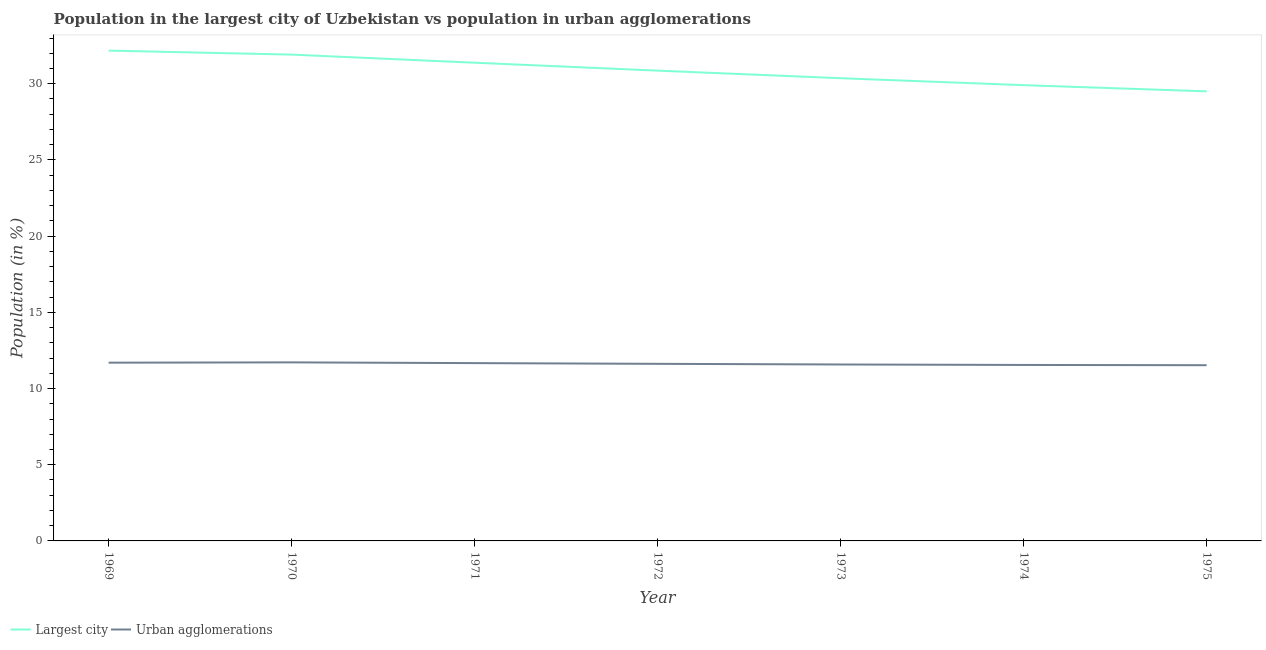Does the line corresponding to population in urban agglomerations intersect with the line corresponding to population in the largest city?
Make the answer very short. No. What is the population in urban agglomerations in 1973?
Offer a terse response. 11.58. Across all years, what is the maximum population in urban agglomerations?
Provide a succinct answer. 11.72. Across all years, what is the minimum population in the largest city?
Keep it short and to the point. 29.5. In which year was the population in the largest city maximum?
Provide a short and direct response. 1969. In which year was the population in urban agglomerations minimum?
Ensure brevity in your answer.  1975. What is the total population in the largest city in the graph?
Offer a very short reply. 216.09. What is the difference between the population in urban agglomerations in 1972 and that in 1975?
Provide a short and direct response. 0.09. What is the difference between the population in the largest city in 1972 and the population in urban agglomerations in 1975?
Your answer should be compact. 19.33. What is the average population in urban agglomerations per year?
Give a very brief answer. 11.62. In the year 1970, what is the difference between the population in the largest city and population in urban agglomerations?
Provide a succinct answer. 20.2. In how many years, is the population in urban agglomerations greater than 14 %?
Provide a succinct answer. 0. What is the ratio of the population in urban agglomerations in 1971 to that in 1974?
Your answer should be compact. 1.01. Is the difference between the population in urban agglomerations in 1970 and 1972 greater than the difference between the population in the largest city in 1970 and 1972?
Keep it short and to the point. No. What is the difference between the highest and the second highest population in urban agglomerations?
Offer a very short reply. 0.02. What is the difference between the highest and the lowest population in urban agglomerations?
Make the answer very short. 0.19. In how many years, is the population in urban agglomerations greater than the average population in urban agglomerations taken over all years?
Keep it short and to the point. 3. Is the population in the largest city strictly less than the population in urban agglomerations over the years?
Make the answer very short. No. What is the difference between two consecutive major ticks on the Y-axis?
Make the answer very short. 5. Does the graph contain any zero values?
Offer a terse response. No. Where does the legend appear in the graph?
Your response must be concise. Bottom left. What is the title of the graph?
Offer a very short reply. Population in the largest city of Uzbekistan vs population in urban agglomerations. What is the Population (in %) in Largest city in 1969?
Keep it short and to the point. 32.17. What is the Population (in %) of Urban agglomerations in 1969?
Provide a short and direct response. 11.7. What is the Population (in %) of Largest city in 1970?
Ensure brevity in your answer.  31.91. What is the Population (in %) in Urban agglomerations in 1970?
Your answer should be very brief. 11.72. What is the Population (in %) of Largest city in 1971?
Your response must be concise. 31.38. What is the Population (in %) of Urban agglomerations in 1971?
Ensure brevity in your answer.  11.67. What is the Population (in %) of Largest city in 1972?
Keep it short and to the point. 30.86. What is the Population (in %) of Urban agglomerations in 1972?
Provide a succinct answer. 11.62. What is the Population (in %) of Largest city in 1973?
Ensure brevity in your answer.  30.36. What is the Population (in %) of Urban agglomerations in 1973?
Offer a terse response. 11.58. What is the Population (in %) in Largest city in 1974?
Offer a terse response. 29.91. What is the Population (in %) of Urban agglomerations in 1974?
Your response must be concise. 11.55. What is the Population (in %) in Largest city in 1975?
Your answer should be compact. 29.5. What is the Population (in %) of Urban agglomerations in 1975?
Your answer should be very brief. 11.53. Across all years, what is the maximum Population (in %) of Largest city?
Provide a short and direct response. 32.17. Across all years, what is the maximum Population (in %) in Urban agglomerations?
Provide a succinct answer. 11.72. Across all years, what is the minimum Population (in %) in Largest city?
Offer a very short reply. 29.5. Across all years, what is the minimum Population (in %) in Urban agglomerations?
Ensure brevity in your answer.  11.53. What is the total Population (in %) of Largest city in the graph?
Your response must be concise. 216.09. What is the total Population (in %) of Urban agglomerations in the graph?
Provide a succinct answer. 81.35. What is the difference between the Population (in %) in Largest city in 1969 and that in 1970?
Your answer should be compact. 0.26. What is the difference between the Population (in %) of Urban agglomerations in 1969 and that in 1970?
Keep it short and to the point. -0.02. What is the difference between the Population (in %) in Largest city in 1969 and that in 1971?
Make the answer very short. 0.79. What is the difference between the Population (in %) of Urban agglomerations in 1969 and that in 1971?
Keep it short and to the point. 0.03. What is the difference between the Population (in %) of Largest city in 1969 and that in 1972?
Give a very brief answer. 1.31. What is the difference between the Population (in %) of Urban agglomerations in 1969 and that in 1972?
Your answer should be compact. 0.08. What is the difference between the Population (in %) in Largest city in 1969 and that in 1973?
Your answer should be compact. 1.81. What is the difference between the Population (in %) in Urban agglomerations in 1969 and that in 1973?
Provide a succinct answer. 0.12. What is the difference between the Population (in %) of Largest city in 1969 and that in 1974?
Provide a succinct answer. 2.27. What is the difference between the Population (in %) of Urban agglomerations in 1969 and that in 1974?
Your response must be concise. 0.15. What is the difference between the Population (in %) of Largest city in 1969 and that in 1975?
Offer a terse response. 2.67. What is the difference between the Population (in %) in Urban agglomerations in 1969 and that in 1975?
Give a very brief answer. 0.17. What is the difference between the Population (in %) in Largest city in 1970 and that in 1971?
Provide a short and direct response. 0.53. What is the difference between the Population (in %) in Urban agglomerations in 1970 and that in 1971?
Make the answer very short. 0.05. What is the difference between the Population (in %) of Largest city in 1970 and that in 1972?
Make the answer very short. 1.05. What is the difference between the Population (in %) in Urban agglomerations in 1970 and that in 1972?
Your answer should be compact. 0.1. What is the difference between the Population (in %) of Largest city in 1970 and that in 1973?
Provide a succinct answer. 1.55. What is the difference between the Population (in %) of Urban agglomerations in 1970 and that in 1973?
Offer a terse response. 0.14. What is the difference between the Population (in %) in Largest city in 1970 and that in 1974?
Provide a short and direct response. 2. What is the difference between the Population (in %) in Urban agglomerations in 1970 and that in 1974?
Your answer should be very brief. 0.17. What is the difference between the Population (in %) in Largest city in 1970 and that in 1975?
Give a very brief answer. 2.41. What is the difference between the Population (in %) of Urban agglomerations in 1970 and that in 1975?
Keep it short and to the point. 0.19. What is the difference between the Population (in %) in Largest city in 1971 and that in 1972?
Ensure brevity in your answer.  0.52. What is the difference between the Population (in %) in Urban agglomerations in 1971 and that in 1972?
Give a very brief answer. 0.05. What is the difference between the Population (in %) in Largest city in 1971 and that in 1973?
Make the answer very short. 1.02. What is the difference between the Population (in %) of Urban agglomerations in 1971 and that in 1973?
Your response must be concise. 0.09. What is the difference between the Population (in %) in Largest city in 1971 and that in 1974?
Your response must be concise. 1.47. What is the difference between the Population (in %) in Urban agglomerations in 1971 and that in 1974?
Your response must be concise. 0.12. What is the difference between the Population (in %) in Largest city in 1971 and that in 1975?
Keep it short and to the point. 1.88. What is the difference between the Population (in %) in Urban agglomerations in 1971 and that in 1975?
Provide a short and direct response. 0.14. What is the difference between the Population (in %) in Largest city in 1972 and that in 1973?
Keep it short and to the point. 0.5. What is the difference between the Population (in %) of Urban agglomerations in 1972 and that in 1973?
Give a very brief answer. 0.04. What is the difference between the Population (in %) of Largest city in 1972 and that in 1974?
Provide a short and direct response. 0.95. What is the difference between the Population (in %) of Urban agglomerations in 1972 and that in 1974?
Your answer should be compact. 0.07. What is the difference between the Population (in %) of Largest city in 1972 and that in 1975?
Your answer should be compact. 1.36. What is the difference between the Population (in %) of Urban agglomerations in 1972 and that in 1975?
Give a very brief answer. 0.09. What is the difference between the Population (in %) of Largest city in 1973 and that in 1974?
Your answer should be compact. 0.46. What is the difference between the Population (in %) of Urban agglomerations in 1973 and that in 1974?
Offer a very short reply. 0.03. What is the difference between the Population (in %) of Largest city in 1973 and that in 1975?
Make the answer very short. 0.86. What is the difference between the Population (in %) in Urban agglomerations in 1973 and that in 1975?
Your answer should be compact. 0.05. What is the difference between the Population (in %) in Largest city in 1974 and that in 1975?
Offer a very short reply. 0.41. What is the difference between the Population (in %) of Urban agglomerations in 1974 and that in 1975?
Your answer should be very brief. 0.02. What is the difference between the Population (in %) in Largest city in 1969 and the Population (in %) in Urban agglomerations in 1970?
Offer a terse response. 20.46. What is the difference between the Population (in %) in Largest city in 1969 and the Population (in %) in Urban agglomerations in 1971?
Provide a short and direct response. 20.51. What is the difference between the Population (in %) in Largest city in 1969 and the Population (in %) in Urban agglomerations in 1972?
Your response must be concise. 20.55. What is the difference between the Population (in %) in Largest city in 1969 and the Population (in %) in Urban agglomerations in 1973?
Give a very brief answer. 20.6. What is the difference between the Population (in %) in Largest city in 1969 and the Population (in %) in Urban agglomerations in 1974?
Provide a short and direct response. 20.63. What is the difference between the Population (in %) in Largest city in 1969 and the Population (in %) in Urban agglomerations in 1975?
Offer a terse response. 20.64. What is the difference between the Population (in %) of Largest city in 1970 and the Population (in %) of Urban agglomerations in 1971?
Keep it short and to the point. 20.24. What is the difference between the Population (in %) in Largest city in 1970 and the Population (in %) in Urban agglomerations in 1972?
Your answer should be compact. 20.29. What is the difference between the Population (in %) of Largest city in 1970 and the Population (in %) of Urban agglomerations in 1973?
Your answer should be very brief. 20.33. What is the difference between the Population (in %) of Largest city in 1970 and the Population (in %) of Urban agglomerations in 1974?
Give a very brief answer. 20.36. What is the difference between the Population (in %) of Largest city in 1970 and the Population (in %) of Urban agglomerations in 1975?
Keep it short and to the point. 20.38. What is the difference between the Population (in %) in Largest city in 1971 and the Population (in %) in Urban agglomerations in 1972?
Make the answer very short. 19.76. What is the difference between the Population (in %) in Largest city in 1971 and the Population (in %) in Urban agglomerations in 1973?
Your response must be concise. 19.8. What is the difference between the Population (in %) of Largest city in 1971 and the Population (in %) of Urban agglomerations in 1974?
Your answer should be very brief. 19.83. What is the difference between the Population (in %) of Largest city in 1971 and the Population (in %) of Urban agglomerations in 1975?
Make the answer very short. 19.85. What is the difference between the Population (in %) in Largest city in 1972 and the Population (in %) in Urban agglomerations in 1973?
Provide a short and direct response. 19.28. What is the difference between the Population (in %) in Largest city in 1972 and the Population (in %) in Urban agglomerations in 1974?
Your answer should be compact. 19.31. What is the difference between the Population (in %) of Largest city in 1972 and the Population (in %) of Urban agglomerations in 1975?
Keep it short and to the point. 19.33. What is the difference between the Population (in %) in Largest city in 1973 and the Population (in %) in Urban agglomerations in 1974?
Ensure brevity in your answer.  18.82. What is the difference between the Population (in %) in Largest city in 1973 and the Population (in %) in Urban agglomerations in 1975?
Give a very brief answer. 18.83. What is the difference between the Population (in %) of Largest city in 1974 and the Population (in %) of Urban agglomerations in 1975?
Provide a short and direct response. 18.38. What is the average Population (in %) of Largest city per year?
Offer a very short reply. 30.87. What is the average Population (in %) in Urban agglomerations per year?
Give a very brief answer. 11.62. In the year 1969, what is the difference between the Population (in %) in Largest city and Population (in %) in Urban agglomerations?
Offer a very short reply. 20.48. In the year 1970, what is the difference between the Population (in %) of Largest city and Population (in %) of Urban agglomerations?
Make the answer very short. 20.2. In the year 1971, what is the difference between the Population (in %) of Largest city and Population (in %) of Urban agglomerations?
Make the answer very short. 19.71. In the year 1972, what is the difference between the Population (in %) of Largest city and Population (in %) of Urban agglomerations?
Offer a terse response. 19.24. In the year 1973, what is the difference between the Population (in %) of Largest city and Population (in %) of Urban agglomerations?
Your response must be concise. 18.78. In the year 1974, what is the difference between the Population (in %) in Largest city and Population (in %) in Urban agglomerations?
Give a very brief answer. 18.36. In the year 1975, what is the difference between the Population (in %) of Largest city and Population (in %) of Urban agglomerations?
Offer a terse response. 17.97. What is the ratio of the Population (in %) in Largest city in 1969 to that in 1970?
Ensure brevity in your answer.  1.01. What is the ratio of the Population (in %) of Largest city in 1969 to that in 1971?
Keep it short and to the point. 1.03. What is the ratio of the Population (in %) of Urban agglomerations in 1969 to that in 1971?
Your answer should be very brief. 1. What is the ratio of the Population (in %) in Largest city in 1969 to that in 1972?
Provide a succinct answer. 1.04. What is the ratio of the Population (in %) of Urban agglomerations in 1969 to that in 1972?
Give a very brief answer. 1.01. What is the ratio of the Population (in %) in Largest city in 1969 to that in 1973?
Offer a terse response. 1.06. What is the ratio of the Population (in %) of Urban agglomerations in 1969 to that in 1973?
Give a very brief answer. 1.01. What is the ratio of the Population (in %) of Largest city in 1969 to that in 1974?
Provide a succinct answer. 1.08. What is the ratio of the Population (in %) of Urban agglomerations in 1969 to that in 1974?
Your response must be concise. 1.01. What is the ratio of the Population (in %) in Largest city in 1969 to that in 1975?
Your answer should be compact. 1.09. What is the ratio of the Population (in %) in Urban agglomerations in 1969 to that in 1975?
Give a very brief answer. 1.01. What is the ratio of the Population (in %) of Largest city in 1970 to that in 1971?
Offer a terse response. 1.02. What is the ratio of the Population (in %) of Largest city in 1970 to that in 1972?
Offer a terse response. 1.03. What is the ratio of the Population (in %) in Urban agglomerations in 1970 to that in 1972?
Make the answer very short. 1.01. What is the ratio of the Population (in %) in Largest city in 1970 to that in 1973?
Offer a very short reply. 1.05. What is the ratio of the Population (in %) in Largest city in 1970 to that in 1974?
Your answer should be compact. 1.07. What is the ratio of the Population (in %) in Urban agglomerations in 1970 to that in 1974?
Your answer should be compact. 1.01. What is the ratio of the Population (in %) in Largest city in 1970 to that in 1975?
Your answer should be very brief. 1.08. What is the ratio of the Population (in %) in Urban agglomerations in 1970 to that in 1975?
Offer a terse response. 1.02. What is the ratio of the Population (in %) of Largest city in 1971 to that in 1972?
Make the answer very short. 1.02. What is the ratio of the Population (in %) of Largest city in 1971 to that in 1973?
Ensure brevity in your answer.  1.03. What is the ratio of the Population (in %) in Urban agglomerations in 1971 to that in 1973?
Keep it short and to the point. 1.01. What is the ratio of the Population (in %) of Largest city in 1971 to that in 1974?
Give a very brief answer. 1.05. What is the ratio of the Population (in %) of Urban agglomerations in 1971 to that in 1974?
Your response must be concise. 1.01. What is the ratio of the Population (in %) of Largest city in 1971 to that in 1975?
Provide a short and direct response. 1.06. What is the ratio of the Population (in %) of Urban agglomerations in 1971 to that in 1975?
Provide a short and direct response. 1.01. What is the ratio of the Population (in %) of Largest city in 1972 to that in 1973?
Your answer should be compact. 1.02. What is the ratio of the Population (in %) of Largest city in 1972 to that in 1974?
Keep it short and to the point. 1.03. What is the ratio of the Population (in %) of Urban agglomerations in 1972 to that in 1974?
Your answer should be very brief. 1.01. What is the ratio of the Population (in %) of Largest city in 1972 to that in 1975?
Ensure brevity in your answer.  1.05. What is the ratio of the Population (in %) in Urban agglomerations in 1972 to that in 1975?
Offer a very short reply. 1.01. What is the ratio of the Population (in %) of Largest city in 1973 to that in 1974?
Keep it short and to the point. 1.02. What is the ratio of the Population (in %) in Urban agglomerations in 1973 to that in 1974?
Provide a short and direct response. 1. What is the ratio of the Population (in %) in Largest city in 1973 to that in 1975?
Make the answer very short. 1.03. What is the ratio of the Population (in %) of Largest city in 1974 to that in 1975?
Your answer should be very brief. 1.01. What is the difference between the highest and the second highest Population (in %) in Largest city?
Your answer should be very brief. 0.26. What is the difference between the highest and the second highest Population (in %) in Urban agglomerations?
Give a very brief answer. 0.02. What is the difference between the highest and the lowest Population (in %) in Largest city?
Give a very brief answer. 2.67. What is the difference between the highest and the lowest Population (in %) in Urban agglomerations?
Keep it short and to the point. 0.19. 